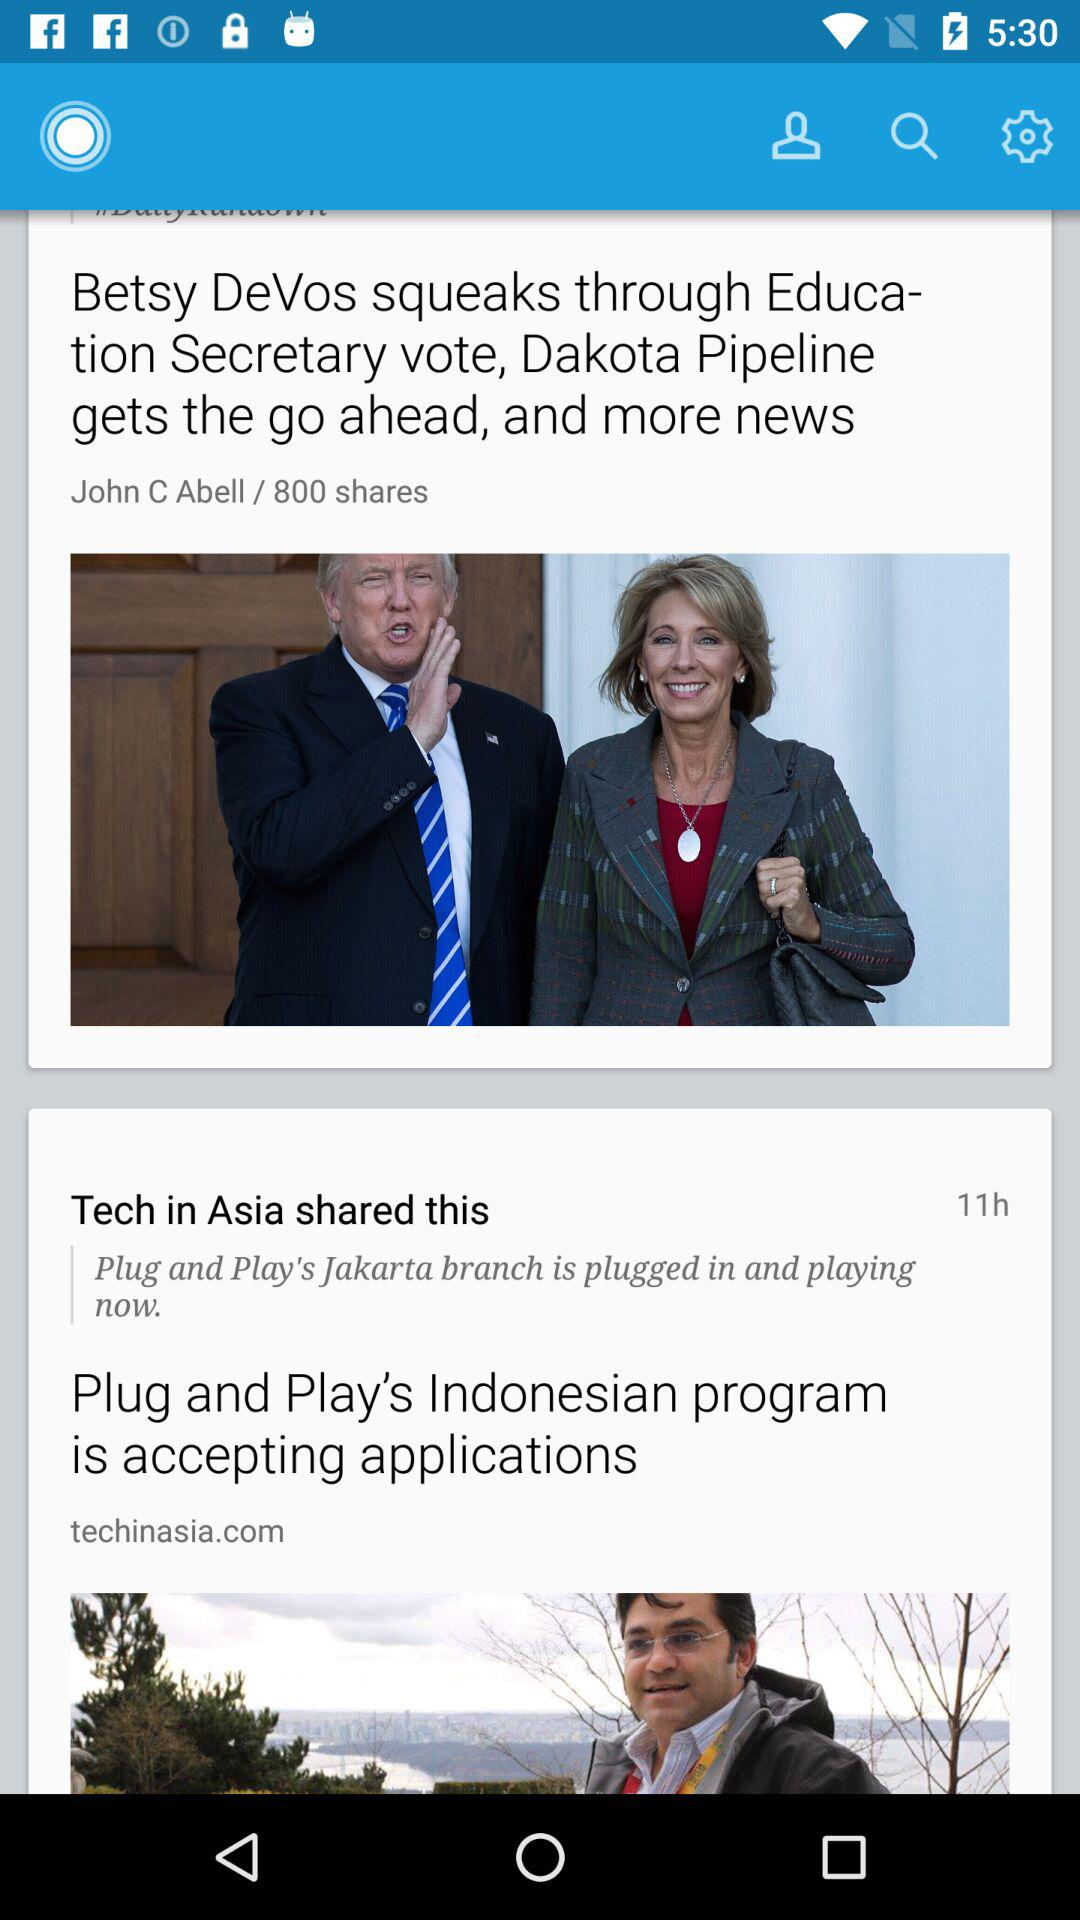How many times has the post been shared? The post has been shared 800 times. 